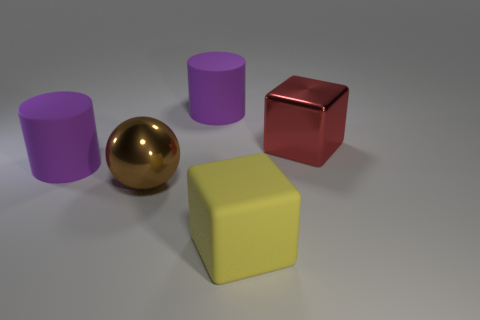There is a big red object; how many purple cylinders are on the right side of it?
Offer a very short reply. 0. Are there any purple objects that have the same material as the sphere?
Your response must be concise. No. There is a large cylinder behind the red cube; what is its color?
Your answer should be very brief. Purple. Are there the same number of brown metallic things that are in front of the ball and big purple rubber cylinders that are in front of the red shiny object?
Provide a succinct answer. No. The large purple object that is right of the shiny object that is to the left of the matte cube is made of what material?
Provide a short and direct response. Rubber. What number of objects are either big gray matte cubes or purple cylinders that are behind the big brown shiny sphere?
Offer a very short reply. 2. The object that is the same material as the big brown sphere is what size?
Keep it short and to the point. Large. Are there more matte cylinders to the left of the big shiny ball than large objects?
Keep it short and to the point. No. There is a big red thing that is the same shape as the big yellow rubber object; what material is it?
Offer a terse response. Metal. There is a rubber thing that is both on the left side of the yellow rubber block and on the right side of the brown thing; what color is it?
Provide a short and direct response. Purple. 